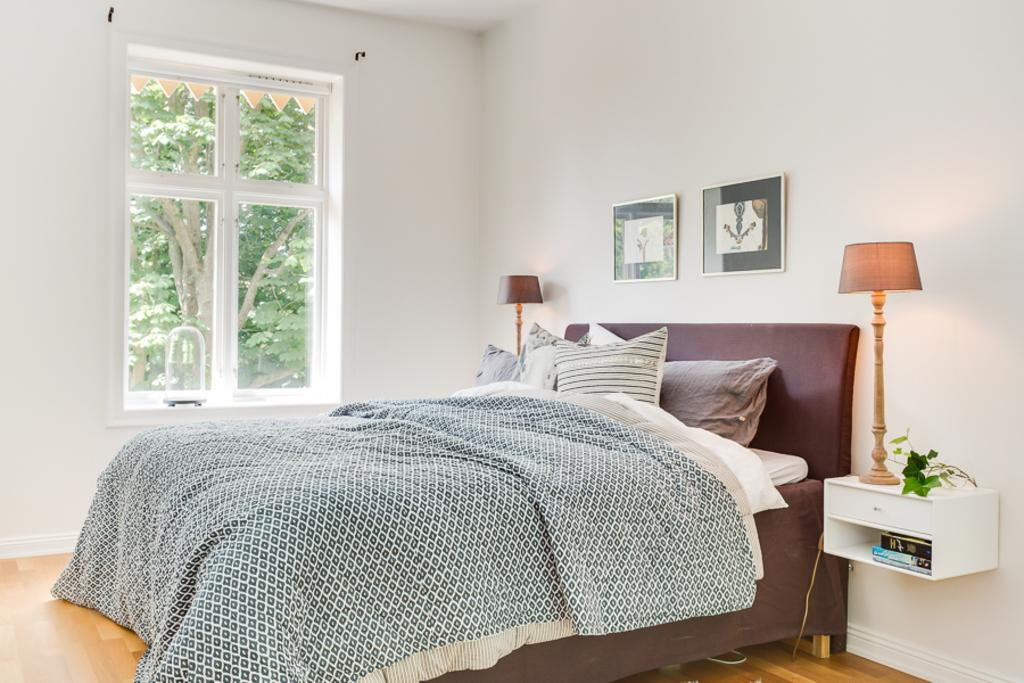What type of space is depicted in the image? The image shows the inside view of a room. What furniture is present in the room? There is a bed in the room. What architectural feature is visible in the room? There is a window in the room. What part of the room can be seen in the image? The floor is visible in the image. What decorative elements are present on the wall? There are frames on the wall. What source of light is present in the room? There is a lamp in the room. Are there any nails visible in the image? There is no mention of nails in the provided facts, so it cannot be determined if any are visible in the image. Can you see any cobwebs in the image? There is no mention of cobwebs in the provided facts, so it cannot be determined if any are visible in the image. 